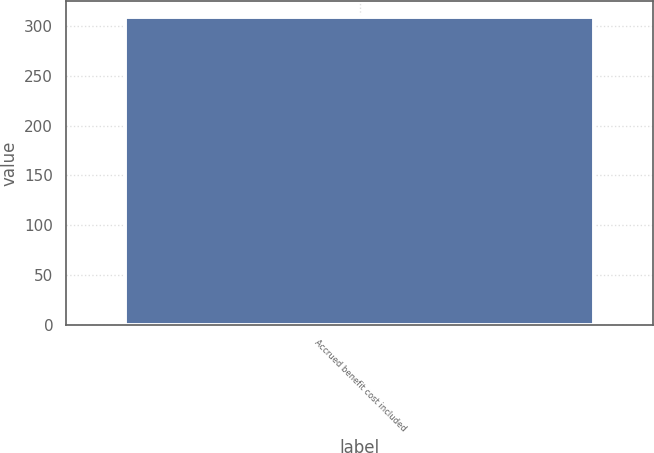Convert chart. <chart><loc_0><loc_0><loc_500><loc_500><bar_chart><fcel>Accrued benefit cost included<nl><fcel>309<nl></chart> 